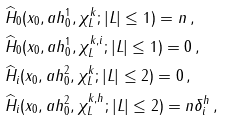Convert formula to latex. <formula><loc_0><loc_0><loc_500><loc_500>& \widehat { H } _ { 0 } ( x _ { 0 } , a h ^ { 1 } _ { 0 } , \chi ^ { k } _ { L } ; | L | \leq 1 ) = n \, , \\ & \widehat { H } _ { 0 } ( x _ { 0 } , a h ^ { 1 } _ { 0 } , \chi ^ { k , i } _ { L } ; | L | \leq 1 ) = 0 \, , \\ & \widehat { H } _ { i } ( x _ { 0 } , a h ^ { 2 } _ { 0 } , \chi ^ { k } _ { L } ; | L | \leq 2 ) = 0 \, , \\ & \widehat { H } _ { i } ( x _ { 0 } , a h ^ { 2 } _ { 0 } , \chi ^ { k , h } _ { L } ; | L | \leq 2 ) = n \delta ^ { h } _ { i } \, ,</formula> 